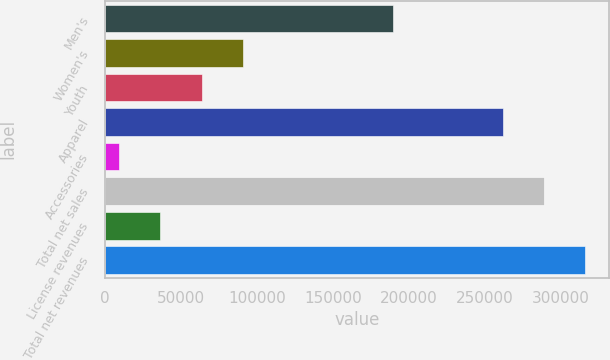<chart> <loc_0><loc_0><loc_500><loc_500><bar_chart><fcel>Men's<fcel>Women's<fcel>Youth<fcel>Apparel<fcel>Accessories<fcel>Total net sales<fcel>License revenues<fcel>Total net revenues<nl><fcel>189596<fcel>90902.2<fcel>63737.8<fcel>261880<fcel>9409<fcel>289044<fcel>36573.4<fcel>316209<nl></chart> 